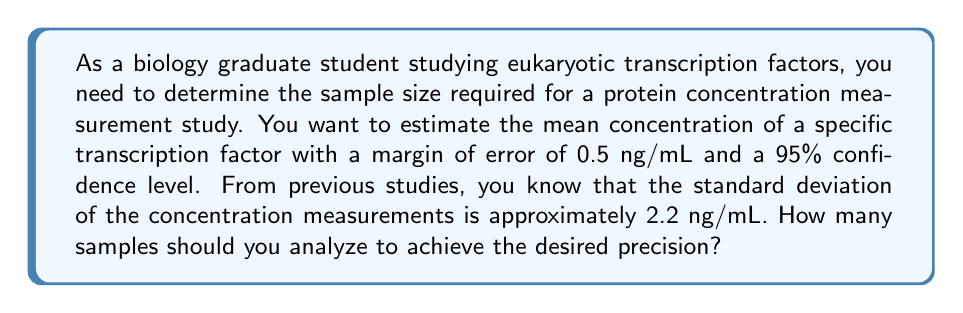Could you help me with this problem? To determine the required sample size, we'll use the formula for the margin of error in a confidence interval for a population mean:

$$ E = z_{\alpha/2} \cdot \frac{\sigma}{\sqrt{n}} $$

Where:
$E$ = margin of error
$z_{\alpha/2}$ = critical value for the desired confidence level
$\sigma$ = population standard deviation
$n$ = sample size

Given:
- Margin of error (E) = 0.5 ng/mL
- Confidence level = 95% (z_{\alpha/2} = 1.96)
- Standard deviation (σ) = 2.2 ng/mL

Step 1: Substitute the known values into the formula and solve for n.

$$ 0.5 = 1.96 \cdot \frac{2.2}{\sqrt{n}} $$

Step 2: Square both sides to isolate n.

$$ (0.5)^2 = (1.96)^2 \cdot \frac{(2.2)^2}{n} $$

Step 3: Multiply both sides by n.

$$ 0.25n = (1.96)^2 \cdot (2.2)^2 $$

Step 4: Solve for n.

$$ n = \frac{(1.96)^2 \cdot (2.2)^2}{0.25} $$

$$ n = \frac{3.8416 \cdot 4.84}{0.25} = 74.19 $$

Step 5: Round up to the nearest whole number, as we can't have a fractional sample size.

$$ n \approx 75 $$

Therefore, you should analyze 75 samples to achieve the desired precision in your protein concentration measurements.
Answer: 75 samples 